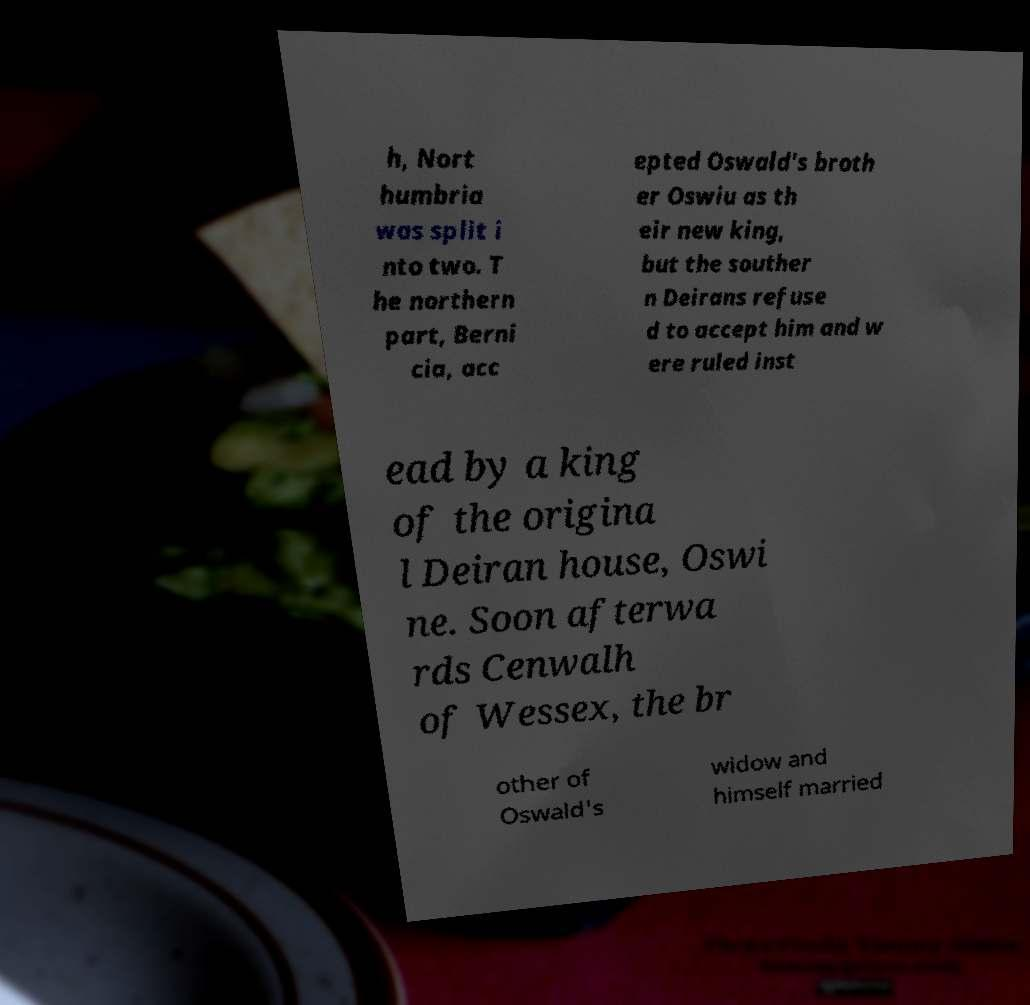Could you extract and type out the text from this image? h, Nort humbria was split i nto two. T he northern part, Berni cia, acc epted Oswald's broth er Oswiu as th eir new king, but the souther n Deirans refuse d to accept him and w ere ruled inst ead by a king of the origina l Deiran house, Oswi ne. Soon afterwa rds Cenwalh of Wessex, the br other of Oswald's widow and himself married 